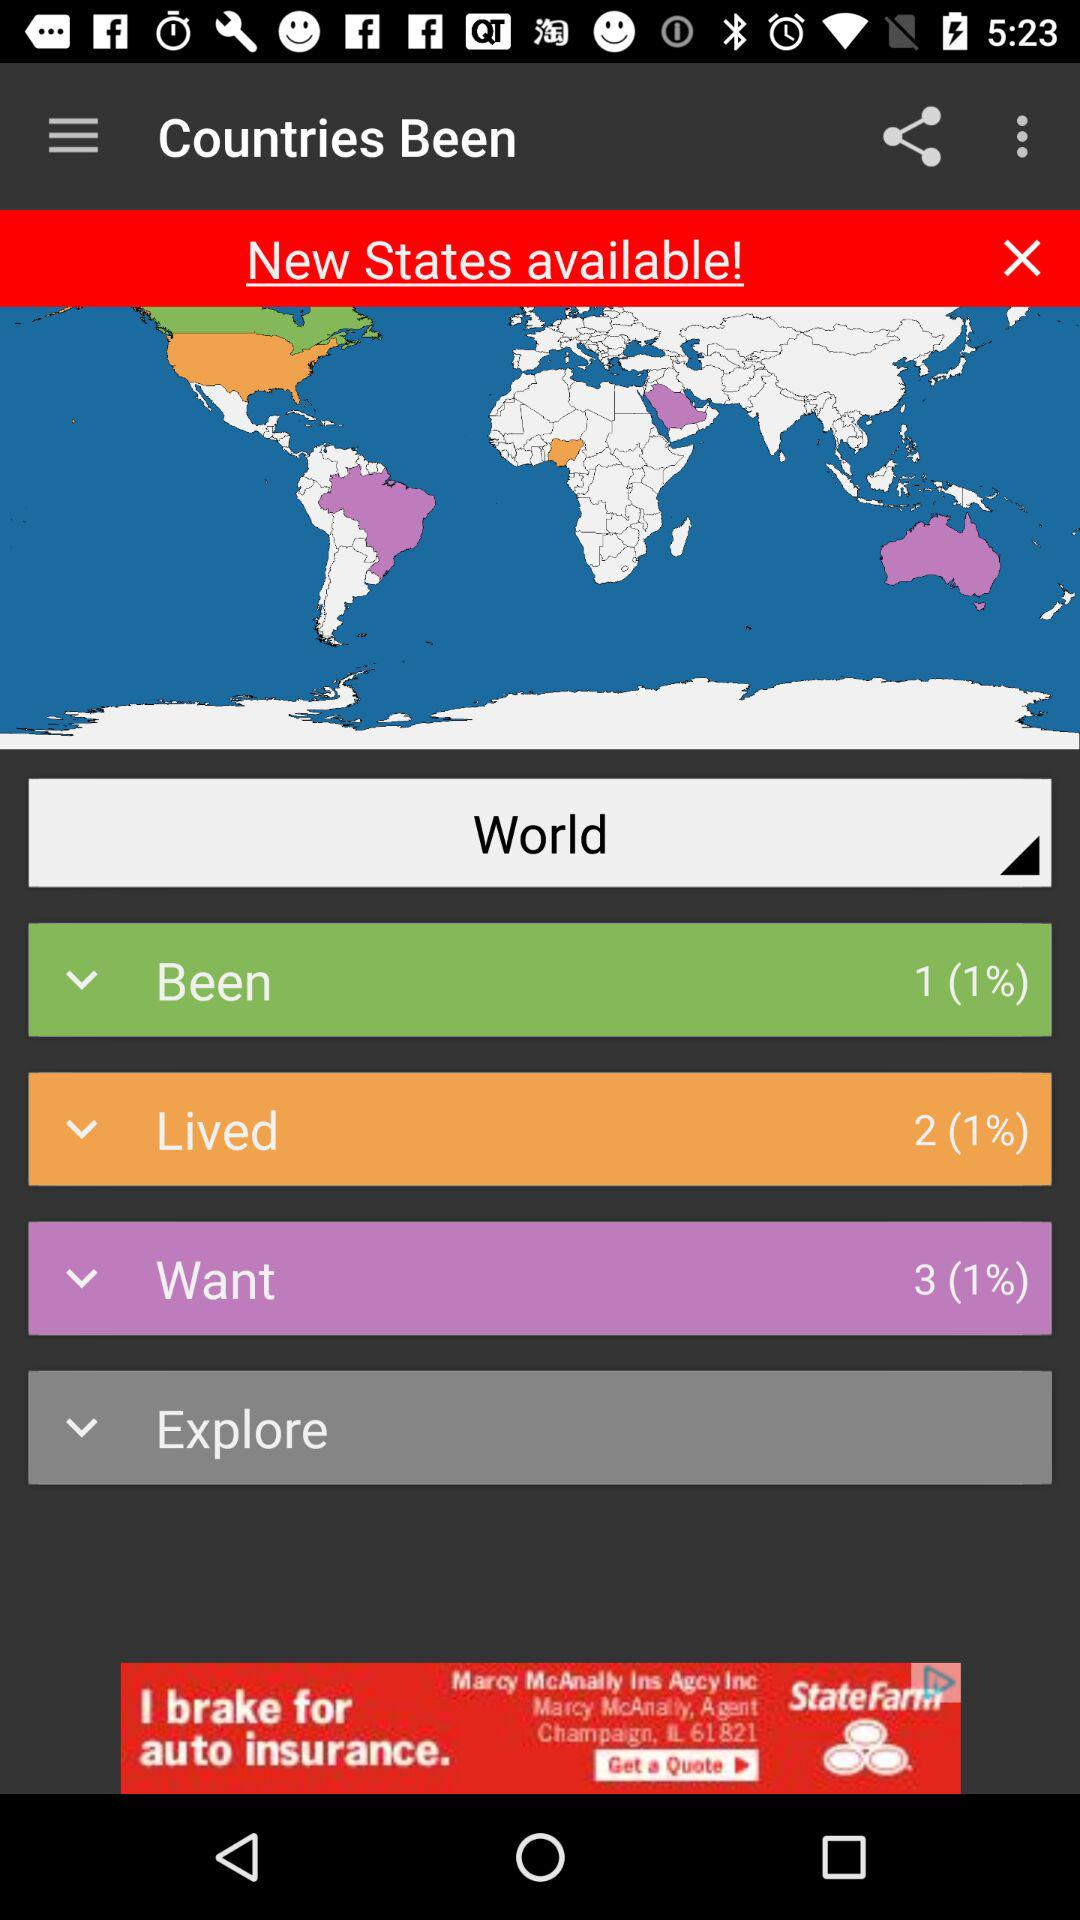What is the percentage of "Lived"? The percentage of "Lived" is 1. 